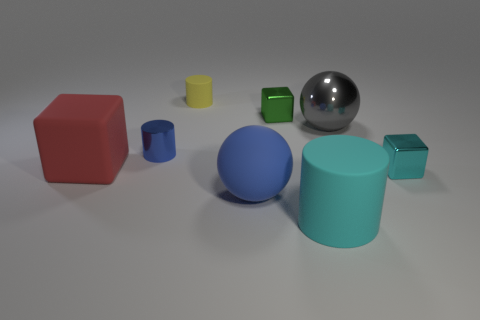Subtract all large blocks. How many blocks are left? 2 Subtract all blue cylinders. How many cylinders are left? 2 Subtract all cubes. How many objects are left? 5 Add 1 tiny yellow things. How many objects exist? 9 Subtract 1 spheres. How many spheres are left? 1 Subtract all tiny green metallic things. Subtract all gray objects. How many objects are left? 6 Add 1 small yellow cylinders. How many small yellow cylinders are left? 2 Add 7 red rubber objects. How many red rubber objects exist? 8 Subtract 0 green cylinders. How many objects are left? 8 Subtract all green cylinders. Subtract all cyan spheres. How many cylinders are left? 3 